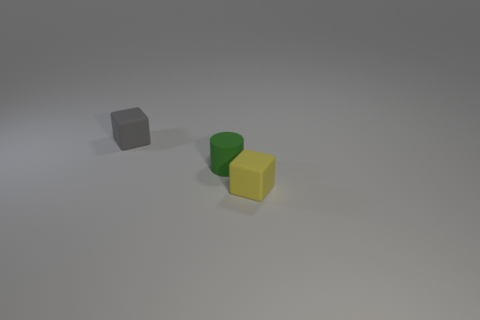How are the items positioned in relation to each other? The green cylinder is to the left of the yellow cube, and the gray block is farther to the left of the green cylinder, creating a diagonal line from left to right with the green cylinder in the middle. Is there any item that appears to have a different texture compared to the others? Yes, the green cylinder has a slightly matte and rubbery texture, while the gray block and the yellow cube seem to have a smoother and more plastic-like texture. 